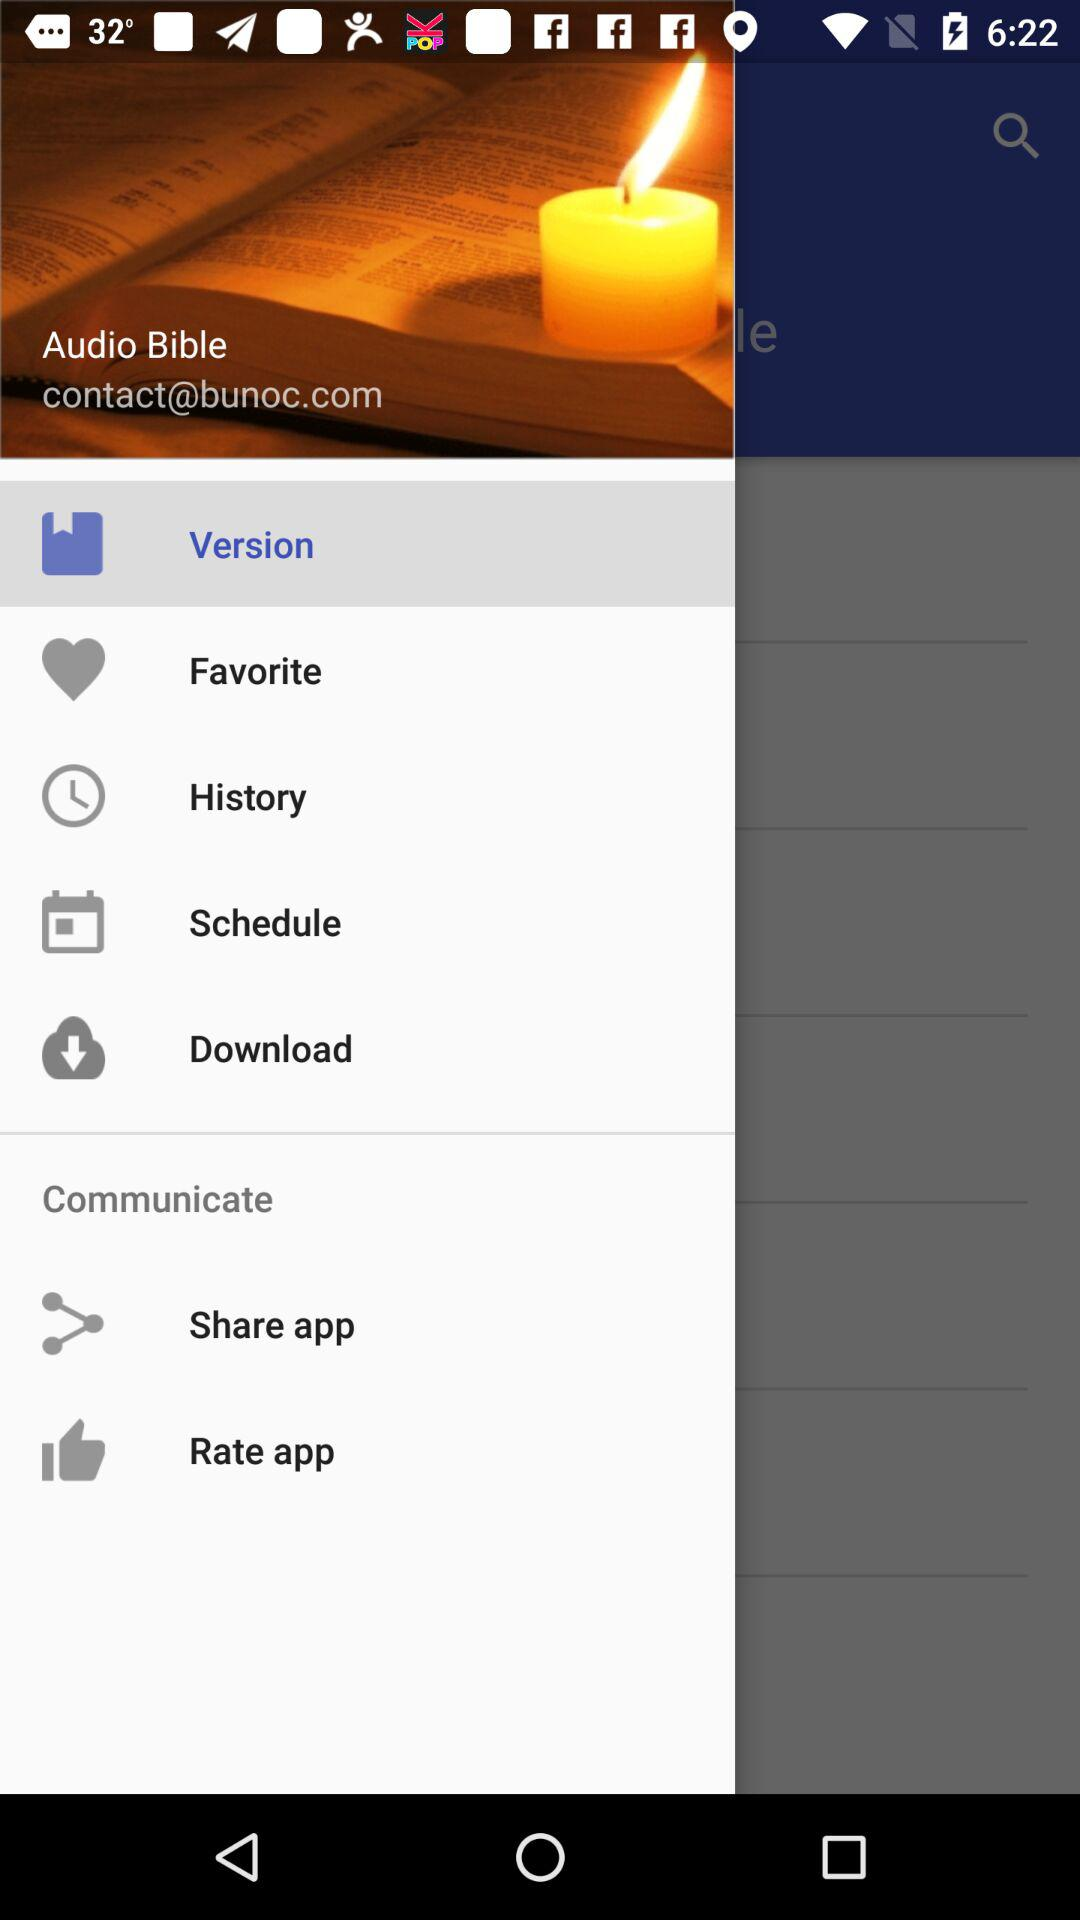What is the selected option? The selected option is "Version". 